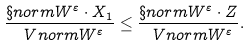Convert formula to latex. <formula><loc_0><loc_0><loc_500><loc_500>\frac { \S n o r m { W ^ { \varepsilon } \cdot X _ { 1 } } } { \ V n o r m { W ^ { \varepsilon } } } \leq \frac { \S n o r m { W ^ { \varepsilon } \cdot Z } } { \ V n o r m { W ^ { \varepsilon } } } .</formula> 